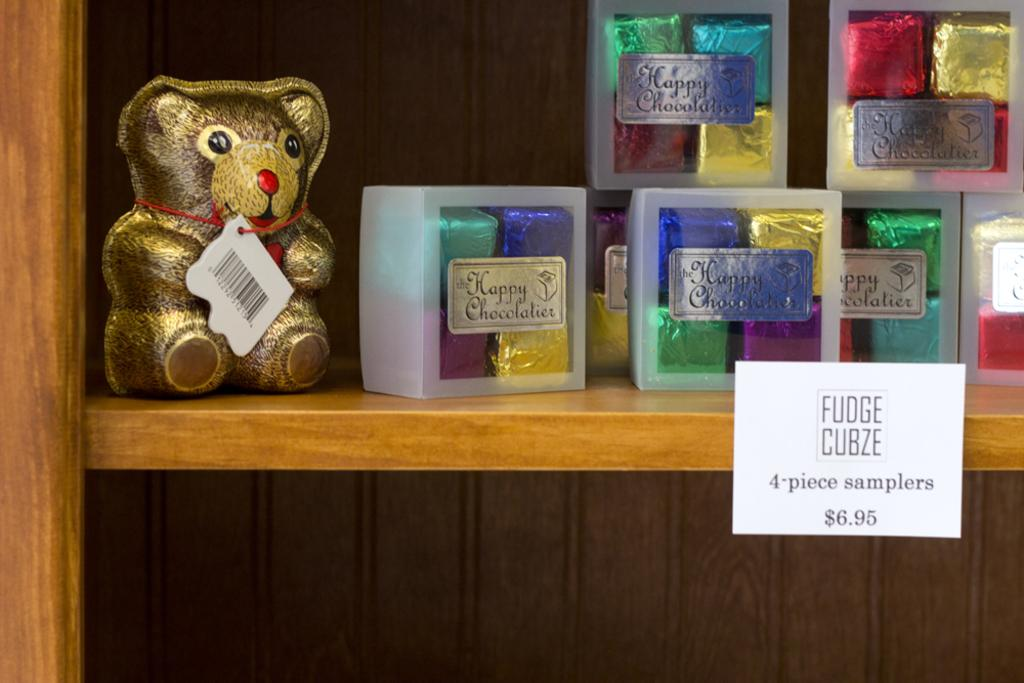<image>
Summarize the visual content of the image. A display of the Happy Chocolatier fudge cubze 